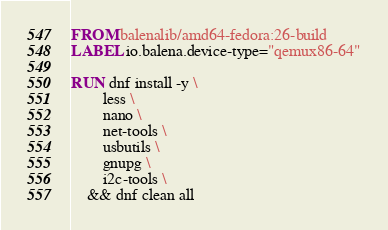Convert code to text. <code><loc_0><loc_0><loc_500><loc_500><_Dockerfile_>FROM balenalib/amd64-fedora:26-build
LABEL io.balena.device-type="qemux86-64"

RUN dnf install -y \
		less \
		nano \
		net-tools \
		usbutils \
		gnupg \
		i2c-tools \
	&& dnf clean all</code> 